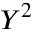<formula> <loc_0><loc_0><loc_500><loc_500>Y ^ { 2 }</formula> 